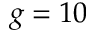Convert formula to latex. <formula><loc_0><loc_0><loc_500><loc_500>g = 1 0</formula> 